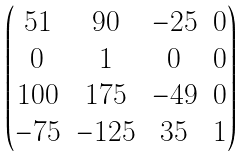<formula> <loc_0><loc_0><loc_500><loc_500>\begin{pmatrix} 5 1 & 9 0 & - 2 5 & 0 \\ 0 & 1 & 0 & 0 \\ 1 0 0 & 1 7 5 & - 4 9 & 0 \\ - 7 5 & - 1 2 5 & 3 5 & 1 \end{pmatrix}</formula> 